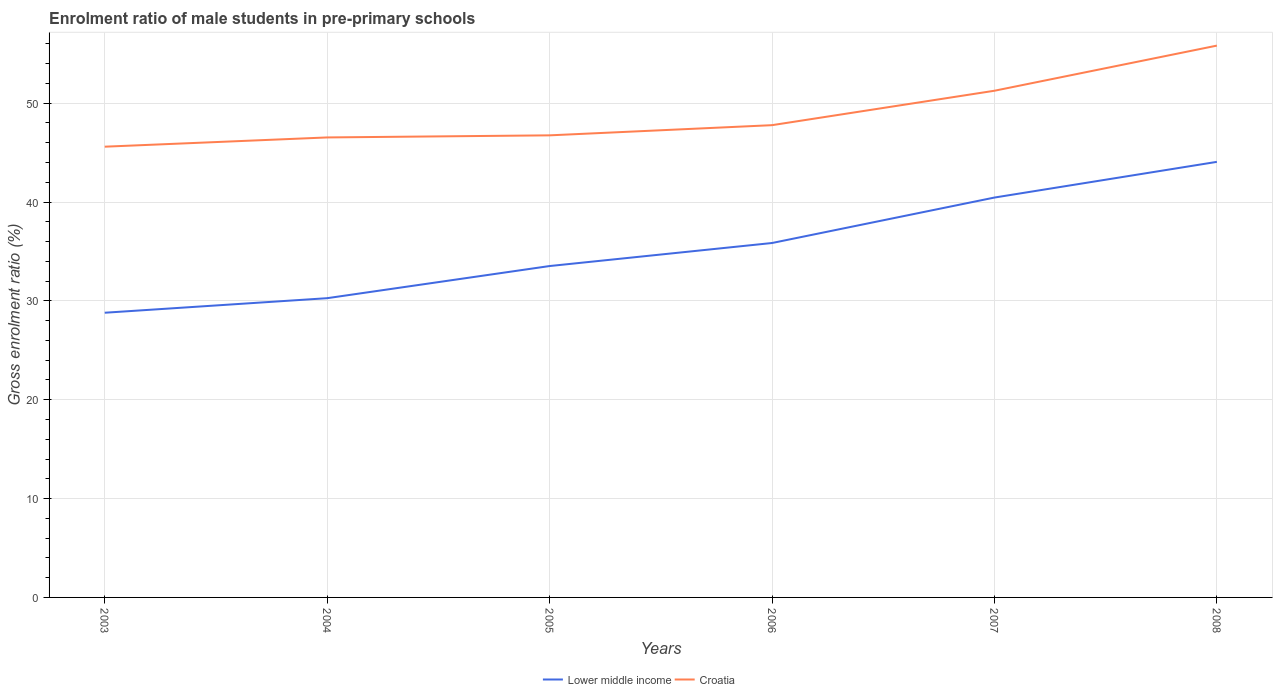How many different coloured lines are there?
Your response must be concise. 2. Does the line corresponding to Croatia intersect with the line corresponding to Lower middle income?
Offer a very short reply. No. Is the number of lines equal to the number of legend labels?
Your response must be concise. Yes. Across all years, what is the maximum enrolment ratio of male students in pre-primary schools in Croatia?
Keep it short and to the point. 45.6. What is the total enrolment ratio of male students in pre-primary schools in Lower middle income in the graph?
Offer a very short reply. -6.93. What is the difference between the highest and the second highest enrolment ratio of male students in pre-primary schools in Lower middle income?
Your answer should be compact. 15.26. What is the difference between the highest and the lowest enrolment ratio of male students in pre-primary schools in Croatia?
Keep it short and to the point. 2. How many lines are there?
Give a very brief answer. 2. How many years are there in the graph?
Provide a succinct answer. 6. What is the difference between two consecutive major ticks on the Y-axis?
Provide a short and direct response. 10. Are the values on the major ticks of Y-axis written in scientific E-notation?
Your answer should be very brief. No. Does the graph contain any zero values?
Provide a succinct answer. No. Does the graph contain grids?
Your answer should be very brief. Yes. How many legend labels are there?
Make the answer very short. 2. How are the legend labels stacked?
Your answer should be very brief. Horizontal. What is the title of the graph?
Your answer should be very brief. Enrolment ratio of male students in pre-primary schools. What is the label or title of the X-axis?
Provide a short and direct response. Years. What is the Gross enrolment ratio (%) of Lower middle income in 2003?
Make the answer very short. 28.8. What is the Gross enrolment ratio (%) of Croatia in 2003?
Offer a terse response. 45.6. What is the Gross enrolment ratio (%) of Lower middle income in 2004?
Provide a short and direct response. 30.28. What is the Gross enrolment ratio (%) in Croatia in 2004?
Offer a terse response. 46.54. What is the Gross enrolment ratio (%) in Lower middle income in 2005?
Your answer should be very brief. 33.53. What is the Gross enrolment ratio (%) in Croatia in 2005?
Your answer should be very brief. 46.75. What is the Gross enrolment ratio (%) of Lower middle income in 2006?
Your response must be concise. 35.86. What is the Gross enrolment ratio (%) in Croatia in 2006?
Provide a short and direct response. 47.78. What is the Gross enrolment ratio (%) in Lower middle income in 2007?
Ensure brevity in your answer.  40.46. What is the Gross enrolment ratio (%) in Croatia in 2007?
Your answer should be compact. 51.26. What is the Gross enrolment ratio (%) of Lower middle income in 2008?
Provide a succinct answer. 44.07. What is the Gross enrolment ratio (%) of Croatia in 2008?
Provide a short and direct response. 55.83. Across all years, what is the maximum Gross enrolment ratio (%) in Lower middle income?
Provide a succinct answer. 44.07. Across all years, what is the maximum Gross enrolment ratio (%) in Croatia?
Your answer should be compact. 55.83. Across all years, what is the minimum Gross enrolment ratio (%) of Lower middle income?
Offer a very short reply. 28.8. Across all years, what is the minimum Gross enrolment ratio (%) in Croatia?
Give a very brief answer. 45.6. What is the total Gross enrolment ratio (%) of Lower middle income in the graph?
Offer a terse response. 212.98. What is the total Gross enrolment ratio (%) in Croatia in the graph?
Your answer should be very brief. 293.76. What is the difference between the Gross enrolment ratio (%) in Lower middle income in 2003 and that in 2004?
Make the answer very short. -1.47. What is the difference between the Gross enrolment ratio (%) of Croatia in 2003 and that in 2004?
Make the answer very short. -0.94. What is the difference between the Gross enrolment ratio (%) in Lower middle income in 2003 and that in 2005?
Your answer should be compact. -4.72. What is the difference between the Gross enrolment ratio (%) of Croatia in 2003 and that in 2005?
Keep it short and to the point. -1.15. What is the difference between the Gross enrolment ratio (%) of Lower middle income in 2003 and that in 2006?
Offer a terse response. -7.05. What is the difference between the Gross enrolment ratio (%) in Croatia in 2003 and that in 2006?
Keep it short and to the point. -2.18. What is the difference between the Gross enrolment ratio (%) in Lower middle income in 2003 and that in 2007?
Keep it short and to the point. -11.65. What is the difference between the Gross enrolment ratio (%) of Croatia in 2003 and that in 2007?
Keep it short and to the point. -5.66. What is the difference between the Gross enrolment ratio (%) of Lower middle income in 2003 and that in 2008?
Your answer should be very brief. -15.26. What is the difference between the Gross enrolment ratio (%) in Croatia in 2003 and that in 2008?
Make the answer very short. -10.23. What is the difference between the Gross enrolment ratio (%) of Lower middle income in 2004 and that in 2005?
Keep it short and to the point. -3.25. What is the difference between the Gross enrolment ratio (%) in Croatia in 2004 and that in 2005?
Provide a succinct answer. -0.21. What is the difference between the Gross enrolment ratio (%) of Lower middle income in 2004 and that in 2006?
Offer a very short reply. -5.58. What is the difference between the Gross enrolment ratio (%) of Croatia in 2004 and that in 2006?
Your response must be concise. -1.24. What is the difference between the Gross enrolment ratio (%) of Lower middle income in 2004 and that in 2007?
Offer a very short reply. -10.18. What is the difference between the Gross enrolment ratio (%) of Croatia in 2004 and that in 2007?
Your answer should be very brief. -4.72. What is the difference between the Gross enrolment ratio (%) of Lower middle income in 2004 and that in 2008?
Offer a terse response. -13.79. What is the difference between the Gross enrolment ratio (%) of Croatia in 2004 and that in 2008?
Offer a very short reply. -9.29. What is the difference between the Gross enrolment ratio (%) of Lower middle income in 2005 and that in 2006?
Provide a short and direct response. -2.33. What is the difference between the Gross enrolment ratio (%) in Croatia in 2005 and that in 2006?
Offer a very short reply. -1.03. What is the difference between the Gross enrolment ratio (%) in Lower middle income in 2005 and that in 2007?
Offer a very short reply. -6.93. What is the difference between the Gross enrolment ratio (%) in Croatia in 2005 and that in 2007?
Offer a very short reply. -4.51. What is the difference between the Gross enrolment ratio (%) of Lower middle income in 2005 and that in 2008?
Offer a very short reply. -10.54. What is the difference between the Gross enrolment ratio (%) in Croatia in 2005 and that in 2008?
Offer a terse response. -9.08. What is the difference between the Gross enrolment ratio (%) in Lower middle income in 2006 and that in 2007?
Keep it short and to the point. -4.6. What is the difference between the Gross enrolment ratio (%) in Croatia in 2006 and that in 2007?
Ensure brevity in your answer.  -3.48. What is the difference between the Gross enrolment ratio (%) of Lower middle income in 2006 and that in 2008?
Make the answer very short. -8.21. What is the difference between the Gross enrolment ratio (%) in Croatia in 2006 and that in 2008?
Give a very brief answer. -8.05. What is the difference between the Gross enrolment ratio (%) of Lower middle income in 2007 and that in 2008?
Keep it short and to the point. -3.61. What is the difference between the Gross enrolment ratio (%) of Croatia in 2007 and that in 2008?
Provide a succinct answer. -4.57. What is the difference between the Gross enrolment ratio (%) of Lower middle income in 2003 and the Gross enrolment ratio (%) of Croatia in 2004?
Keep it short and to the point. -17.73. What is the difference between the Gross enrolment ratio (%) in Lower middle income in 2003 and the Gross enrolment ratio (%) in Croatia in 2005?
Make the answer very short. -17.95. What is the difference between the Gross enrolment ratio (%) of Lower middle income in 2003 and the Gross enrolment ratio (%) of Croatia in 2006?
Give a very brief answer. -18.98. What is the difference between the Gross enrolment ratio (%) of Lower middle income in 2003 and the Gross enrolment ratio (%) of Croatia in 2007?
Your answer should be compact. -22.46. What is the difference between the Gross enrolment ratio (%) of Lower middle income in 2003 and the Gross enrolment ratio (%) of Croatia in 2008?
Offer a very short reply. -27.03. What is the difference between the Gross enrolment ratio (%) of Lower middle income in 2004 and the Gross enrolment ratio (%) of Croatia in 2005?
Give a very brief answer. -16.47. What is the difference between the Gross enrolment ratio (%) in Lower middle income in 2004 and the Gross enrolment ratio (%) in Croatia in 2006?
Keep it short and to the point. -17.5. What is the difference between the Gross enrolment ratio (%) of Lower middle income in 2004 and the Gross enrolment ratio (%) of Croatia in 2007?
Your response must be concise. -20.99. What is the difference between the Gross enrolment ratio (%) of Lower middle income in 2004 and the Gross enrolment ratio (%) of Croatia in 2008?
Make the answer very short. -25.55. What is the difference between the Gross enrolment ratio (%) of Lower middle income in 2005 and the Gross enrolment ratio (%) of Croatia in 2006?
Give a very brief answer. -14.25. What is the difference between the Gross enrolment ratio (%) of Lower middle income in 2005 and the Gross enrolment ratio (%) of Croatia in 2007?
Offer a very short reply. -17.73. What is the difference between the Gross enrolment ratio (%) of Lower middle income in 2005 and the Gross enrolment ratio (%) of Croatia in 2008?
Offer a very short reply. -22.3. What is the difference between the Gross enrolment ratio (%) of Lower middle income in 2006 and the Gross enrolment ratio (%) of Croatia in 2007?
Keep it short and to the point. -15.4. What is the difference between the Gross enrolment ratio (%) in Lower middle income in 2006 and the Gross enrolment ratio (%) in Croatia in 2008?
Your answer should be very brief. -19.97. What is the difference between the Gross enrolment ratio (%) of Lower middle income in 2007 and the Gross enrolment ratio (%) of Croatia in 2008?
Offer a terse response. -15.37. What is the average Gross enrolment ratio (%) of Lower middle income per year?
Ensure brevity in your answer.  35.5. What is the average Gross enrolment ratio (%) of Croatia per year?
Give a very brief answer. 48.96. In the year 2003, what is the difference between the Gross enrolment ratio (%) in Lower middle income and Gross enrolment ratio (%) in Croatia?
Keep it short and to the point. -16.8. In the year 2004, what is the difference between the Gross enrolment ratio (%) of Lower middle income and Gross enrolment ratio (%) of Croatia?
Provide a succinct answer. -16.26. In the year 2005, what is the difference between the Gross enrolment ratio (%) in Lower middle income and Gross enrolment ratio (%) in Croatia?
Your response must be concise. -13.22. In the year 2006, what is the difference between the Gross enrolment ratio (%) in Lower middle income and Gross enrolment ratio (%) in Croatia?
Offer a terse response. -11.92. In the year 2007, what is the difference between the Gross enrolment ratio (%) of Lower middle income and Gross enrolment ratio (%) of Croatia?
Offer a terse response. -10.81. In the year 2008, what is the difference between the Gross enrolment ratio (%) in Lower middle income and Gross enrolment ratio (%) in Croatia?
Provide a short and direct response. -11.76. What is the ratio of the Gross enrolment ratio (%) in Lower middle income in 2003 to that in 2004?
Offer a very short reply. 0.95. What is the ratio of the Gross enrolment ratio (%) in Croatia in 2003 to that in 2004?
Make the answer very short. 0.98. What is the ratio of the Gross enrolment ratio (%) of Lower middle income in 2003 to that in 2005?
Provide a short and direct response. 0.86. What is the ratio of the Gross enrolment ratio (%) of Croatia in 2003 to that in 2005?
Provide a short and direct response. 0.98. What is the ratio of the Gross enrolment ratio (%) of Lower middle income in 2003 to that in 2006?
Ensure brevity in your answer.  0.8. What is the ratio of the Gross enrolment ratio (%) in Croatia in 2003 to that in 2006?
Your answer should be very brief. 0.95. What is the ratio of the Gross enrolment ratio (%) of Lower middle income in 2003 to that in 2007?
Give a very brief answer. 0.71. What is the ratio of the Gross enrolment ratio (%) of Croatia in 2003 to that in 2007?
Ensure brevity in your answer.  0.89. What is the ratio of the Gross enrolment ratio (%) of Lower middle income in 2003 to that in 2008?
Your response must be concise. 0.65. What is the ratio of the Gross enrolment ratio (%) in Croatia in 2003 to that in 2008?
Keep it short and to the point. 0.82. What is the ratio of the Gross enrolment ratio (%) in Lower middle income in 2004 to that in 2005?
Your answer should be compact. 0.9. What is the ratio of the Gross enrolment ratio (%) of Croatia in 2004 to that in 2005?
Your answer should be very brief. 1. What is the ratio of the Gross enrolment ratio (%) of Lower middle income in 2004 to that in 2006?
Provide a succinct answer. 0.84. What is the ratio of the Gross enrolment ratio (%) of Croatia in 2004 to that in 2006?
Keep it short and to the point. 0.97. What is the ratio of the Gross enrolment ratio (%) in Lower middle income in 2004 to that in 2007?
Your response must be concise. 0.75. What is the ratio of the Gross enrolment ratio (%) of Croatia in 2004 to that in 2007?
Keep it short and to the point. 0.91. What is the ratio of the Gross enrolment ratio (%) in Lower middle income in 2004 to that in 2008?
Offer a terse response. 0.69. What is the ratio of the Gross enrolment ratio (%) in Croatia in 2004 to that in 2008?
Your answer should be very brief. 0.83. What is the ratio of the Gross enrolment ratio (%) in Lower middle income in 2005 to that in 2006?
Provide a short and direct response. 0.94. What is the ratio of the Gross enrolment ratio (%) of Croatia in 2005 to that in 2006?
Make the answer very short. 0.98. What is the ratio of the Gross enrolment ratio (%) in Lower middle income in 2005 to that in 2007?
Offer a very short reply. 0.83. What is the ratio of the Gross enrolment ratio (%) in Croatia in 2005 to that in 2007?
Provide a succinct answer. 0.91. What is the ratio of the Gross enrolment ratio (%) in Lower middle income in 2005 to that in 2008?
Provide a succinct answer. 0.76. What is the ratio of the Gross enrolment ratio (%) of Croatia in 2005 to that in 2008?
Make the answer very short. 0.84. What is the ratio of the Gross enrolment ratio (%) in Lower middle income in 2006 to that in 2007?
Your response must be concise. 0.89. What is the ratio of the Gross enrolment ratio (%) of Croatia in 2006 to that in 2007?
Give a very brief answer. 0.93. What is the ratio of the Gross enrolment ratio (%) in Lower middle income in 2006 to that in 2008?
Your answer should be very brief. 0.81. What is the ratio of the Gross enrolment ratio (%) of Croatia in 2006 to that in 2008?
Provide a short and direct response. 0.86. What is the ratio of the Gross enrolment ratio (%) in Lower middle income in 2007 to that in 2008?
Your answer should be compact. 0.92. What is the ratio of the Gross enrolment ratio (%) in Croatia in 2007 to that in 2008?
Your answer should be very brief. 0.92. What is the difference between the highest and the second highest Gross enrolment ratio (%) of Lower middle income?
Your response must be concise. 3.61. What is the difference between the highest and the second highest Gross enrolment ratio (%) of Croatia?
Ensure brevity in your answer.  4.57. What is the difference between the highest and the lowest Gross enrolment ratio (%) of Lower middle income?
Give a very brief answer. 15.26. What is the difference between the highest and the lowest Gross enrolment ratio (%) of Croatia?
Make the answer very short. 10.23. 